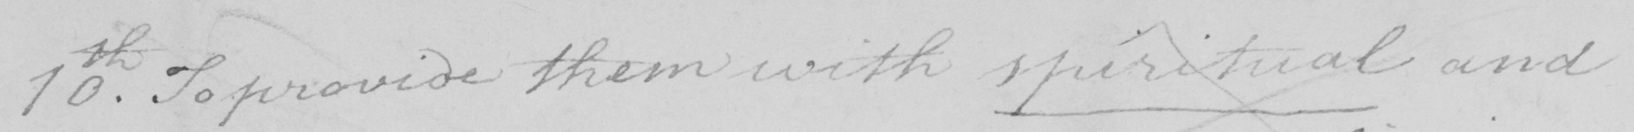What is written in this line of handwriting? 10th . To provide them with spiritual and 